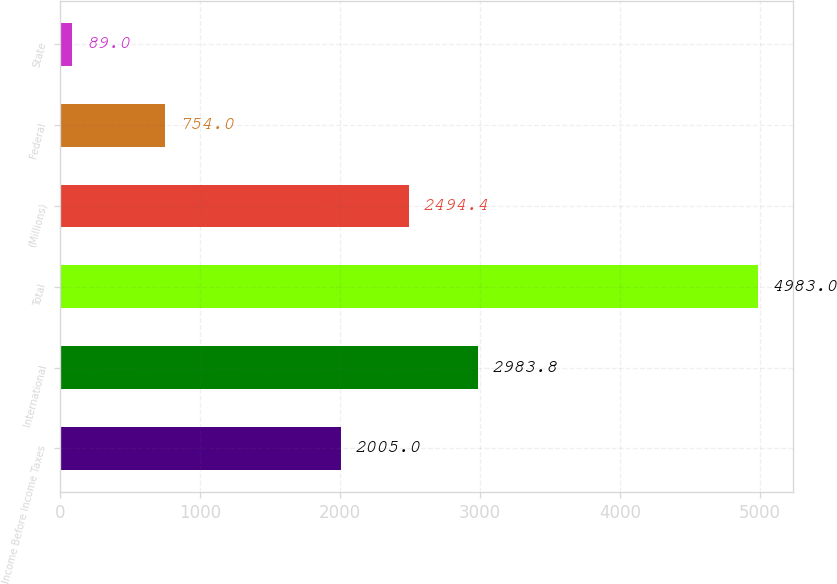Convert chart. <chart><loc_0><loc_0><loc_500><loc_500><bar_chart><fcel>Income Before Income Taxes<fcel>International<fcel>Total<fcel>(Millions)<fcel>Federal<fcel>State<nl><fcel>2005<fcel>2983.8<fcel>4983<fcel>2494.4<fcel>754<fcel>89<nl></chart> 